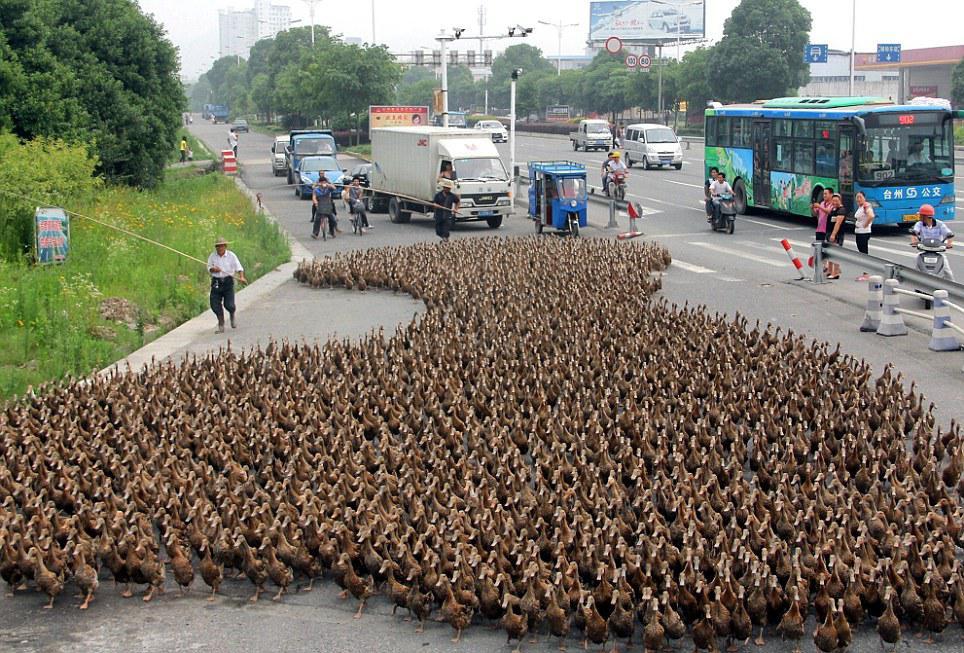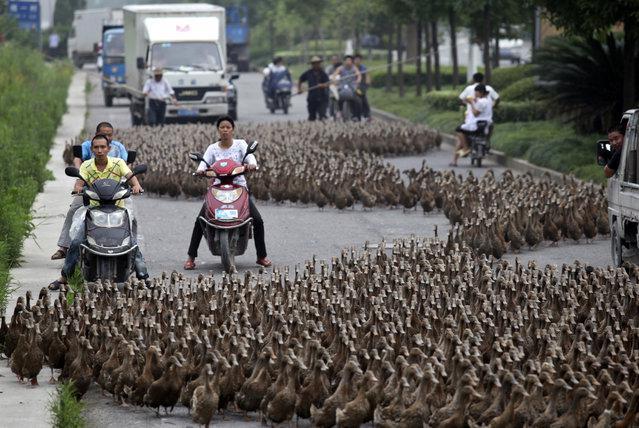The first image is the image on the left, the second image is the image on the right. Examine the images to the left and right. Is the description "There is an officer with yellow marked clothing in the street in one of the images." accurate? Answer yes or no. No. The first image is the image on the left, the second image is the image on the right. Considering the images on both sides, is "There are some police involved, where the geese are blocking the street." valid? Answer yes or no. No. 